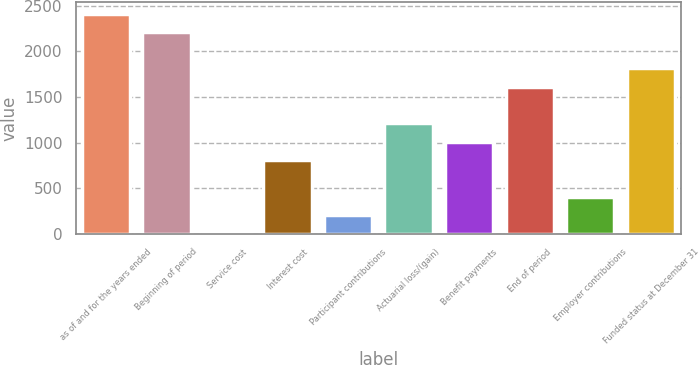<chart> <loc_0><loc_0><loc_500><loc_500><bar_chart><fcel>as of and for the years ended<fcel>Beginning of period<fcel>Service cost<fcel>Interest cost<fcel>Participant contributions<fcel>Actuarial loss/(gain)<fcel>Benefit payments<fcel>End of period<fcel>Employer contributions<fcel>Funded status at December 31<nl><fcel>2413.6<fcel>2213.3<fcel>10<fcel>811.2<fcel>210.3<fcel>1211.8<fcel>1011.5<fcel>1612.4<fcel>410.6<fcel>1812.7<nl></chart> 